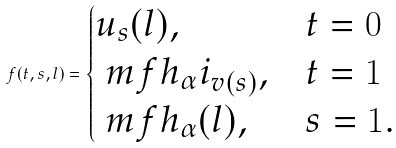<formula> <loc_0><loc_0><loc_500><loc_500>f ( t , s , l ) = \begin{cases} u _ { s } ( l ) , & t = 0 \\ \ m f h _ { \alpha } i _ { v ( s ) } , & t = 1 \\ \ m f h _ { \alpha } ( l ) , & s = 1 . \end{cases}</formula> 